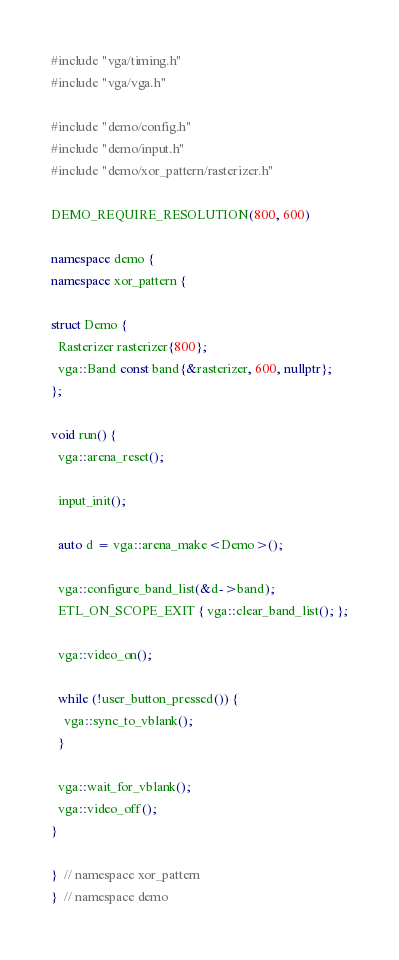<code> <loc_0><loc_0><loc_500><loc_500><_C++_>#include "vga/timing.h"
#include "vga/vga.h"

#include "demo/config.h"
#include "demo/input.h"
#include "demo/xor_pattern/rasterizer.h"

DEMO_REQUIRE_RESOLUTION(800, 600)

namespace demo {
namespace xor_pattern {

struct Demo {
  Rasterizer rasterizer{800};
  vga::Band const band{&rasterizer, 600, nullptr};
};

void run() {
  vga::arena_reset();

  input_init();

  auto d = vga::arena_make<Demo>();

  vga::configure_band_list(&d->band);
  ETL_ON_SCOPE_EXIT { vga::clear_band_list(); };

  vga::video_on();

  while (!user_button_pressed()) {
    vga::sync_to_vblank();
  }

  vga::wait_for_vblank();
  vga::video_off();
}

}  // namespace xor_pattern
}  // namespace demo
</code> 